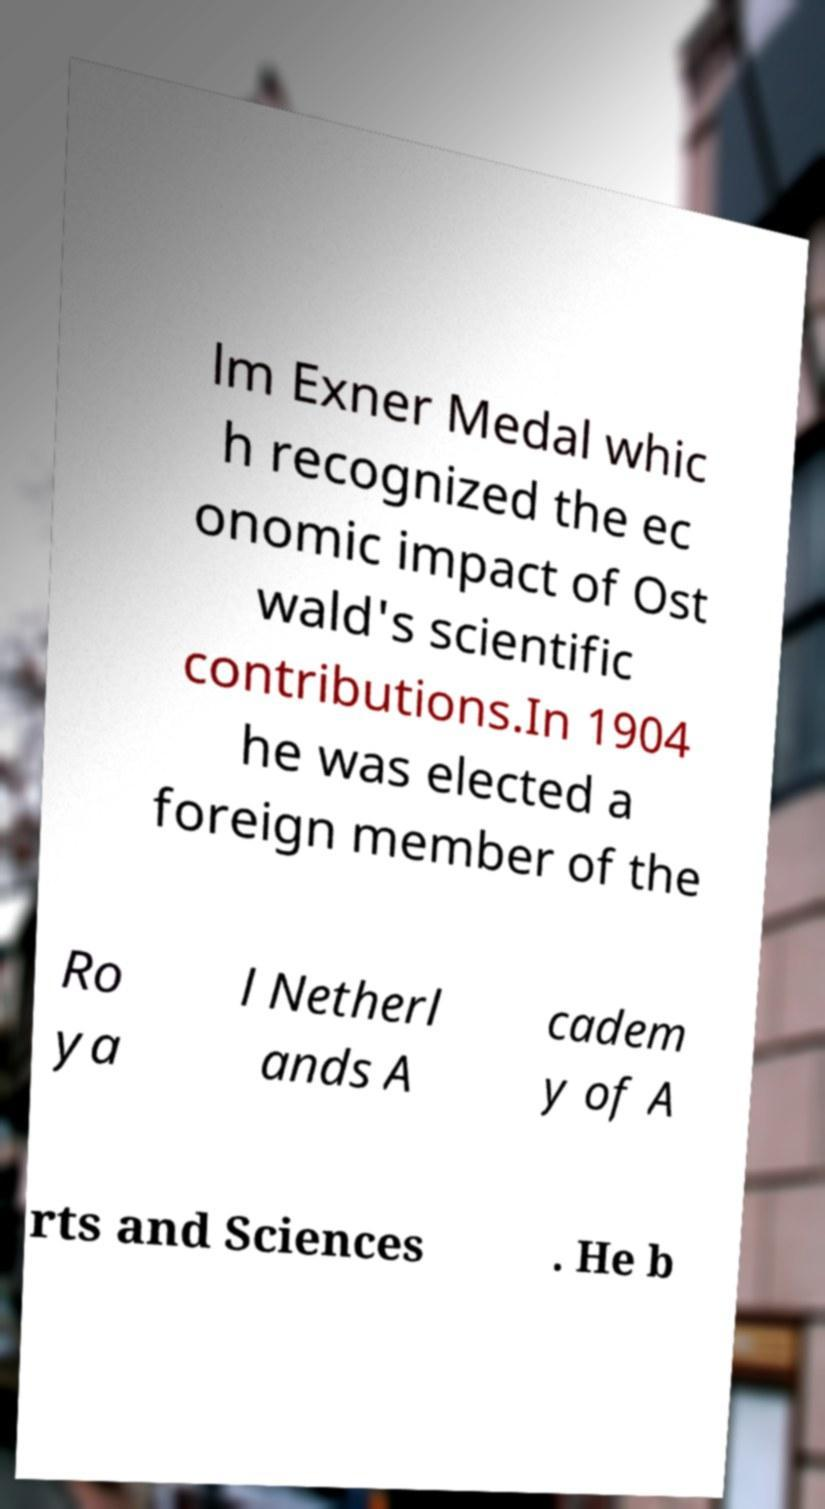Please identify and transcribe the text found in this image. lm Exner Medal whic h recognized the ec onomic impact of Ost wald's scientific contributions.In 1904 he was elected a foreign member of the Ro ya l Netherl ands A cadem y of A rts and Sciences . He b 